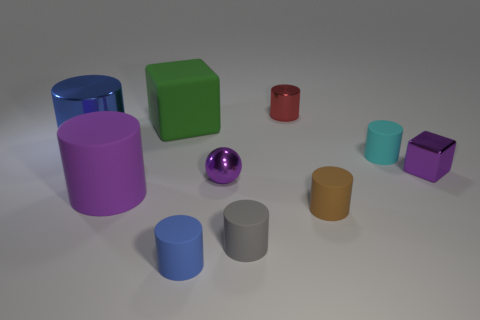There is a cylinder behind the blue cylinder that is to the left of the purple rubber cylinder; what color is it?
Provide a succinct answer. Red. What color is the metal sphere that is the same size as the purple block?
Offer a very short reply. Purple. Is there a small blue thing that has the same shape as the small gray object?
Provide a succinct answer. Yes. The tiny cyan thing has what shape?
Ensure brevity in your answer.  Cylinder. Is the number of small things behind the large purple cylinder greater than the number of large objects to the right of the gray thing?
Offer a terse response. Yes. What number of other objects are the same size as the gray cylinder?
Your answer should be compact. 6. What material is the large thing that is both in front of the large green block and behind the tiny purple ball?
Your answer should be compact. Metal. What material is the red thing that is the same shape as the brown matte object?
Offer a very short reply. Metal. There is a rubber cylinder that is behind the large cylinder in front of the tiny purple metal ball; how many small purple cubes are in front of it?
Offer a terse response. 1. Is there anything else that has the same color as the small metallic cylinder?
Make the answer very short. No. 